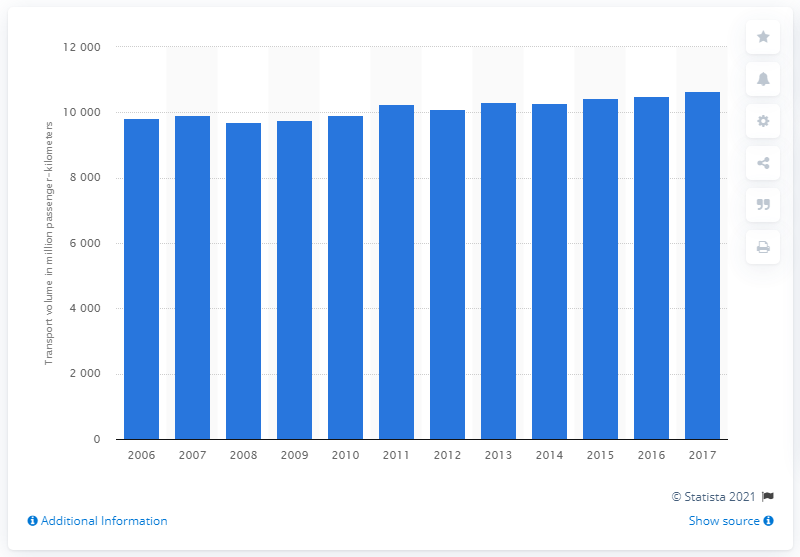List a handful of essential elements in this visual. In 2017, the highest number of passenger-kilometers was reached, which marked the peak of passenger volume. In 2008, the passenger volume in Sweden was 9,692. 